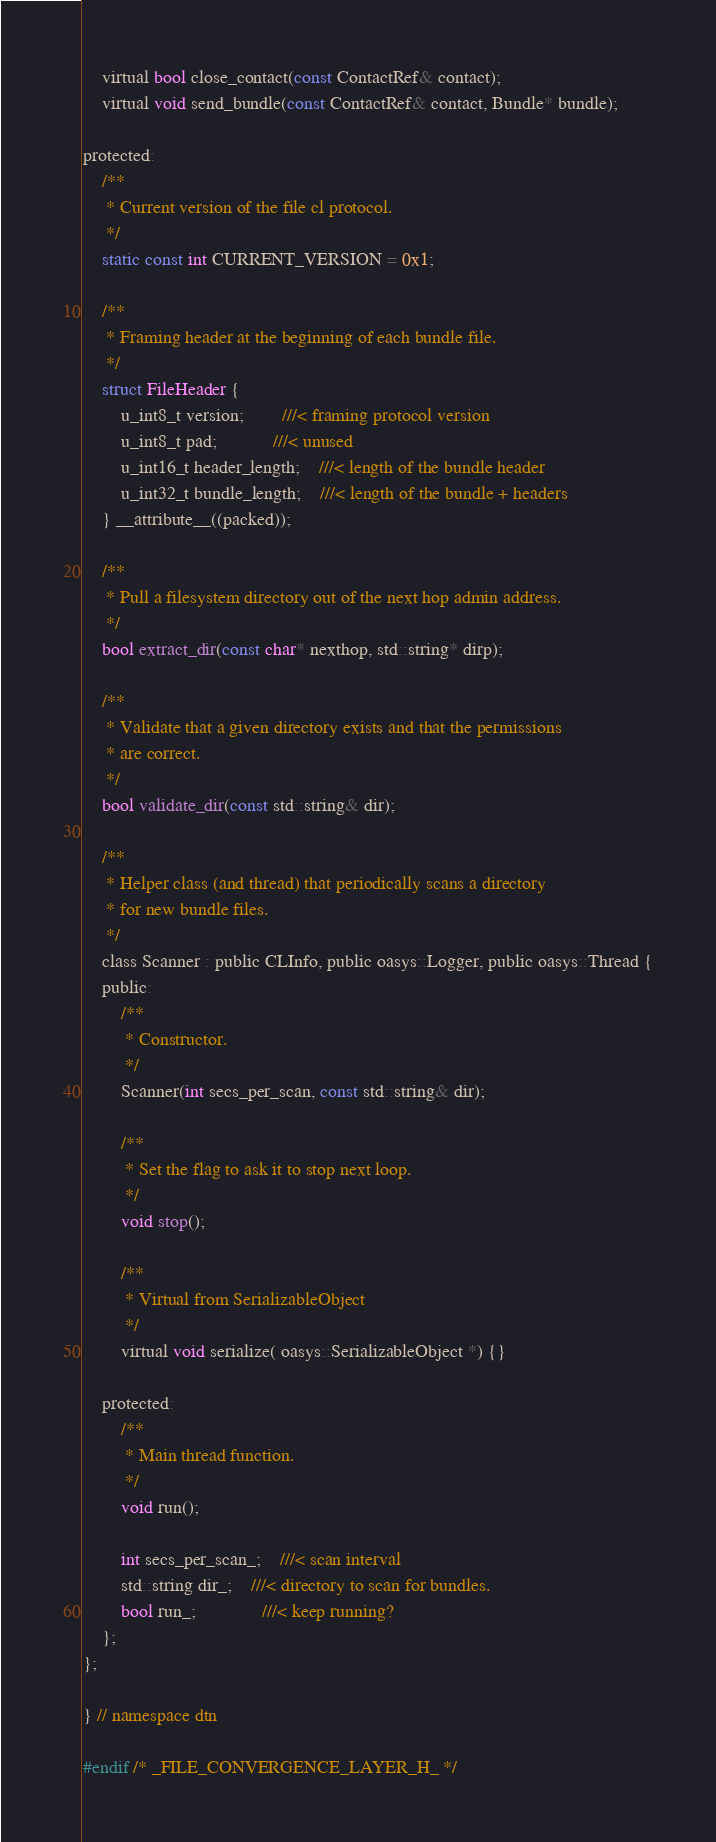<code> <loc_0><loc_0><loc_500><loc_500><_C_>    virtual bool close_contact(const ContactRef& contact);
    virtual void send_bundle(const ContactRef& contact, Bundle* bundle);

protected:
    /**
     * Current version of the file cl protocol.
     */
    static const int CURRENT_VERSION = 0x1;
     
    /**
     * Framing header at the beginning of each bundle file.
     */
    struct FileHeader {
        u_int8_t version;		///< framing protocol version
        u_int8_t pad;			///< unused
        u_int16_t header_length;	///< length of the bundle header
        u_int32_t bundle_length;	///< length of the bundle + headers
    } __attribute__((packed));
    
    /**
     * Pull a filesystem directory out of the next hop admin address.
     */
    bool extract_dir(const char* nexthop, std::string* dirp);
    
    /**
     * Validate that a given directory exists and that the permissions
     * are correct.
     */
    bool validate_dir(const std::string& dir);
        
    /**
     * Helper class (and thread) that periodically scans a directory
     * for new bundle files.
     */
    class Scanner : public CLInfo, public oasys::Logger, public oasys::Thread {
    public:
        /**
         * Constructor.
         */
        Scanner(int secs_per_scan, const std::string& dir);

        /**
         * Set the flag to ask it to stop next loop.
         */
        void stop();

        /**
         * Virtual from SerializableObject
         */
        virtual void serialize( oasys::SerializableObject *) {}

    protected:
        /**
         * Main thread function.
         */
        void run();
        
        int secs_per_scan_;	///< scan interval
        std::string dir_;	///< directory to scan for bundles.
        bool run_;              ///< keep running?
    };
};

} // namespace dtn

#endif /* _FILE_CONVERGENCE_LAYER_H_ */
</code> 